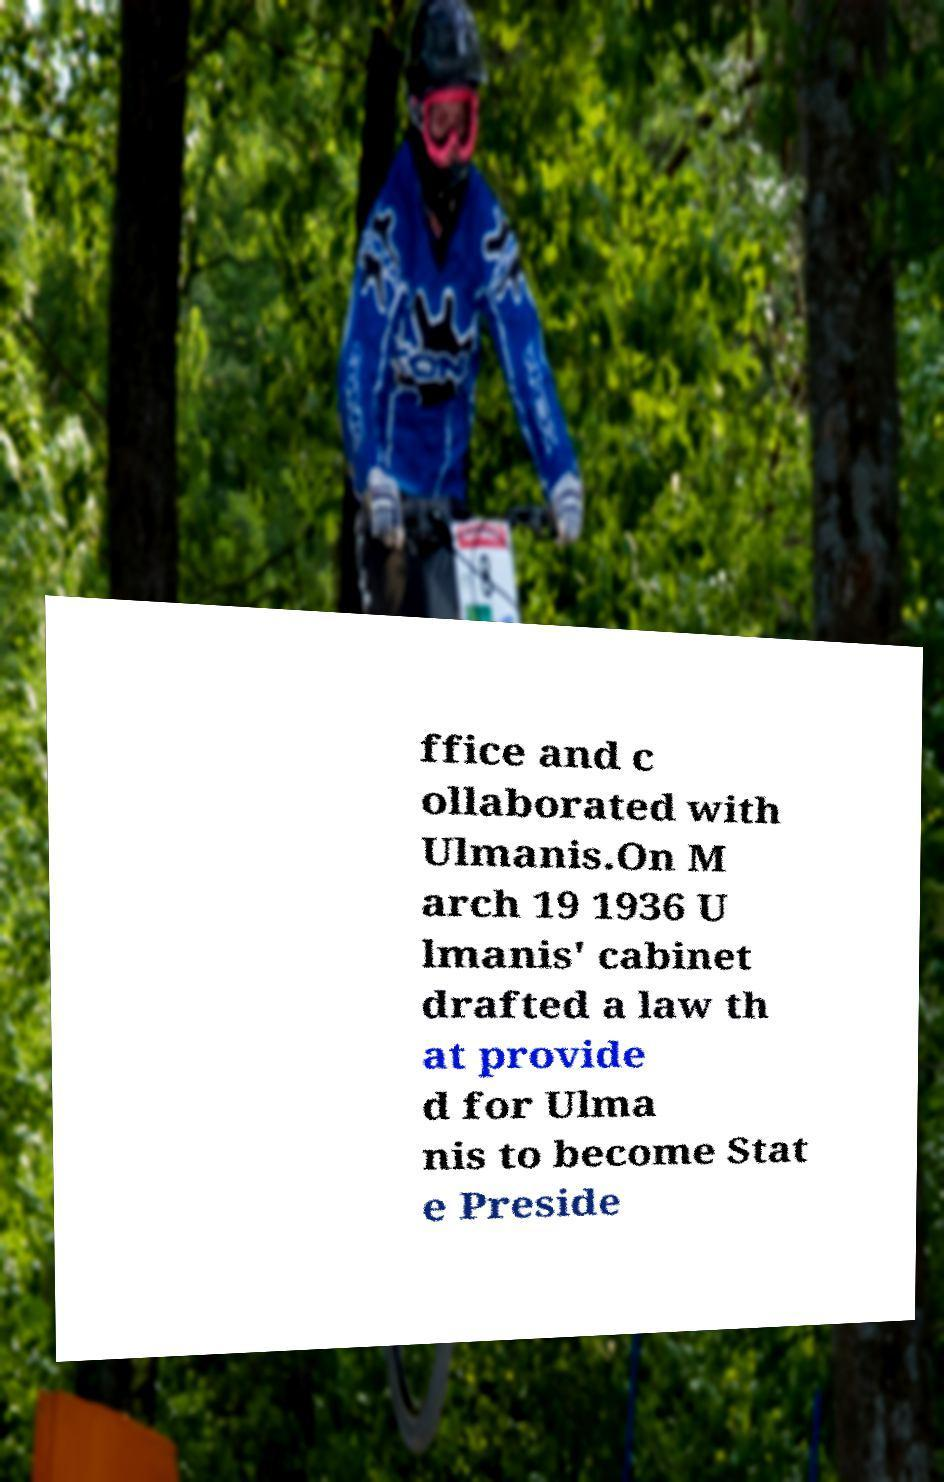Could you assist in decoding the text presented in this image and type it out clearly? ffice and c ollaborated with Ulmanis.On M arch 19 1936 U lmanis' cabinet drafted a law th at provide d for Ulma nis to become Stat e Preside 